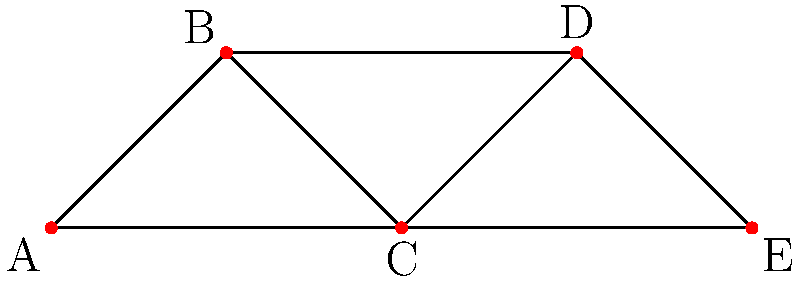In the network graph representing collaborations between indigenous and contemporary artists, what is the minimum number of collaborations that need to be removed to disconnect artist C from artist E? To solve this problem, we need to analyze the paths between artists C and E in the network graph. Let's follow these steps:

1. Identify all paths between C and E:
   - Path 1: C - D - E
   - Path 2: C - E (direct connection)

2. Count the number of distinct paths: There are 2 paths.

3. Apply Menger's theorem: The minimum number of edges to be removed to disconnect two vertices is equal to the maximum number of edge-disjoint paths between them.

4. Observe that the two paths we identified are edge-disjoint, meaning they don't share any common edges.

5. Therefore, the minimum number of collaborations that need to be removed to disconnect C from E is equal to the number of edge-disjoint paths, which is 2.

This means that removing any single collaboration would not be sufficient to disconnect C from E, as there would still be a remaining path between them.
Answer: 2 collaborations 